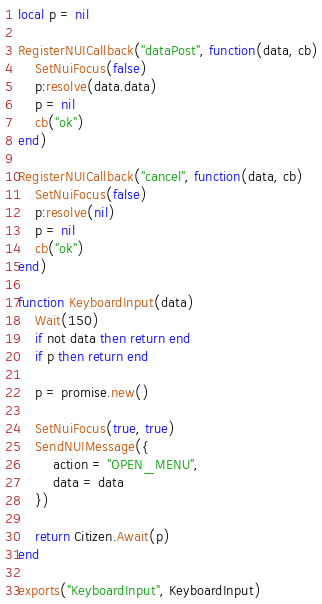<code> <loc_0><loc_0><loc_500><loc_500><_Lua_>local p = nil

RegisterNUICallback("dataPost", function(data, cb)
    SetNuiFocus(false)
    p:resolve(data.data)
    p = nil
    cb("ok")
end)

RegisterNUICallback("cancel", function(data, cb)
    SetNuiFocus(false)
    p:resolve(nil)
    p = nil
    cb("ok")
end)

function KeyboardInput(data)
    Wait(150)
    if not data then return end
    if p then return end
    
    p = promise.new()

    SetNuiFocus(true, true)
    SendNUIMessage({
        action = "OPEN_MENU",
        data = data
    })

    return Citizen.Await(p)
end

exports("KeyboardInput", KeyboardInput)</code> 